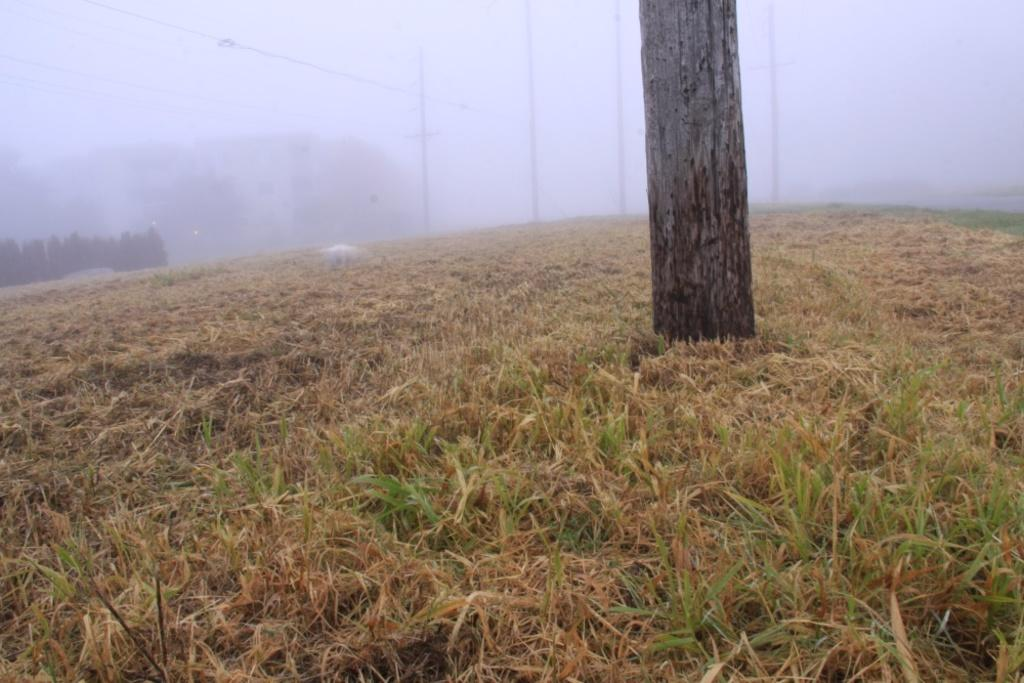What type of vegetation can be seen in the image? There is grass in the image. What structure is visible in the foreground of the image? There is a tree trunk in the image. What can be seen in the background of the image? There are poles, wires, trees, and fog in the background of the image. What type of emotion is displayed by the jellyfish in the image? There are no jellyfish present in the image, so it is not possible to determine any emotions displayed by them. 